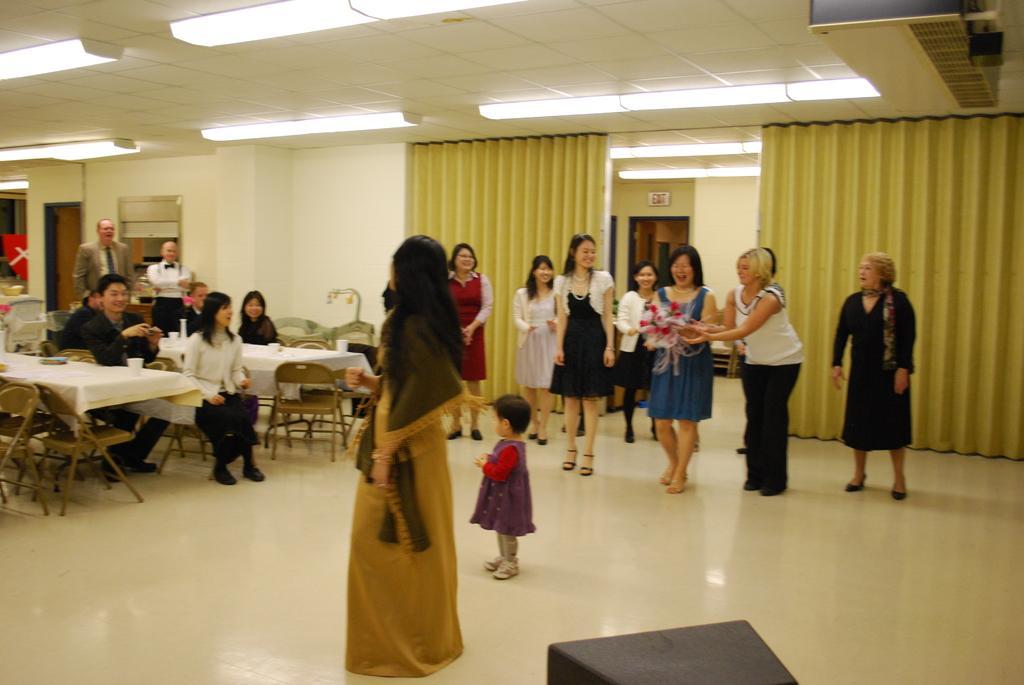Could you give a brief overview of what you see in this image? There are many people standing. IN the center a small girl is standing. Also a woman wearing a blue dress is holding a flower bouquet. Also there are many tables and chairs. On the chairs there are many people sitting. On the ceiling there are lights. In the background there are curtains. Also there is an EXIT board and a door. 